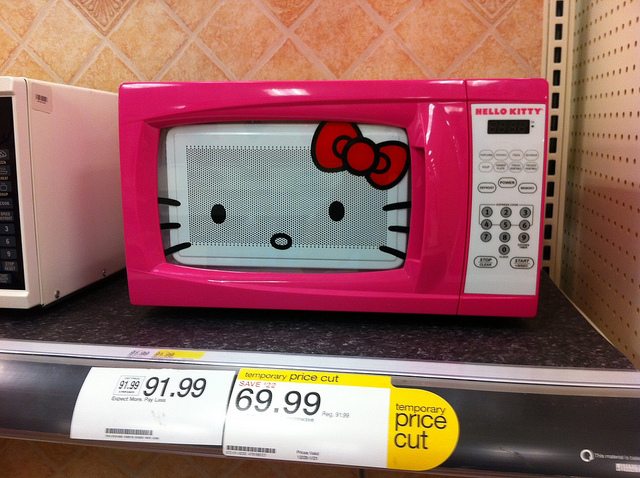Read and extract the text from this image. KITTY HELLO price 69 .99 5 temporary cut SAVE Cut price 91.99 91.99 